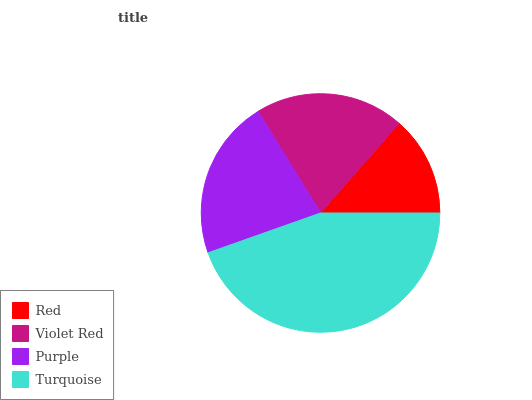Is Red the minimum?
Answer yes or no. Yes. Is Turquoise the maximum?
Answer yes or no. Yes. Is Violet Red the minimum?
Answer yes or no. No. Is Violet Red the maximum?
Answer yes or no. No. Is Violet Red greater than Red?
Answer yes or no. Yes. Is Red less than Violet Red?
Answer yes or no. Yes. Is Red greater than Violet Red?
Answer yes or no. No. Is Violet Red less than Red?
Answer yes or no. No. Is Purple the high median?
Answer yes or no. Yes. Is Violet Red the low median?
Answer yes or no. Yes. Is Violet Red the high median?
Answer yes or no. No. Is Purple the low median?
Answer yes or no. No. 